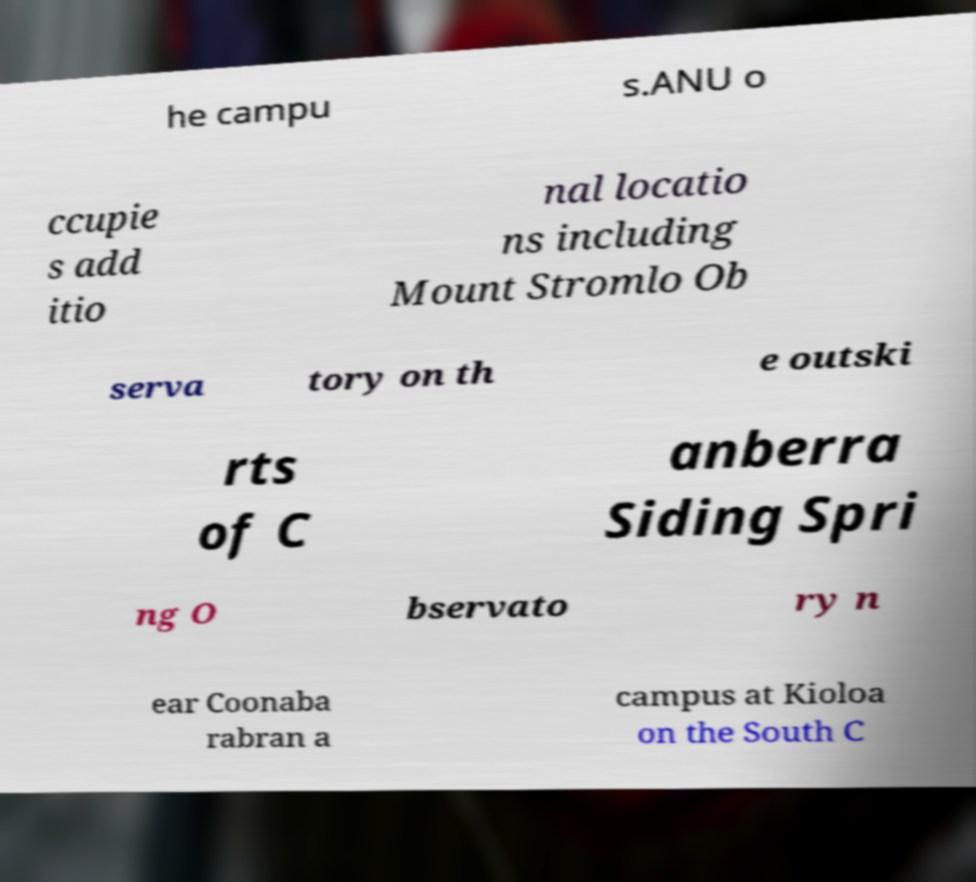I need the written content from this picture converted into text. Can you do that? he campu s.ANU o ccupie s add itio nal locatio ns including Mount Stromlo Ob serva tory on th e outski rts of C anberra Siding Spri ng O bservato ry n ear Coonaba rabran a campus at Kioloa on the South C 